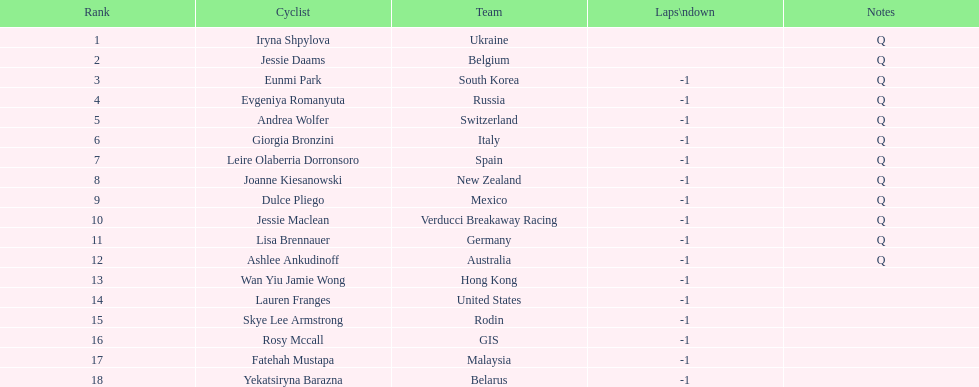Could you help me parse every detail presented in this table? {'header': ['Rank', 'Cyclist', 'Team', 'Laps\\ndown', 'Notes'], 'rows': [['1', 'Iryna Shpylova', 'Ukraine', '', 'Q'], ['2', 'Jessie Daams', 'Belgium', '', 'Q'], ['3', 'Eunmi Park', 'South Korea', '-1', 'Q'], ['4', 'Evgeniya Romanyuta', 'Russia', '-1', 'Q'], ['5', 'Andrea Wolfer', 'Switzerland', '-1', 'Q'], ['6', 'Giorgia Bronzini', 'Italy', '-1', 'Q'], ['7', 'Leire Olaberria Dorronsoro', 'Spain', '-1', 'Q'], ['8', 'Joanne Kiesanowski', 'New Zealand', '-1', 'Q'], ['9', 'Dulce Pliego', 'Mexico', '-1', 'Q'], ['10', 'Jessie Maclean', 'Verducci Breakaway Racing', '-1', 'Q'], ['11', 'Lisa Brennauer', 'Germany', '-1', 'Q'], ['12', 'Ashlee Ankudinoff', 'Australia', '-1', 'Q'], ['13', 'Wan Yiu Jamie Wong', 'Hong Kong', '-1', ''], ['14', 'Lauren Franges', 'United States', '-1', ''], ['15', 'Skye Lee Armstrong', 'Rodin', '-1', ''], ['16', 'Rosy Mccall', 'GIS', '-1', ''], ['17', 'Fatehah Mustapa', 'Malaysia', '-1', ''], ['18', 'Yekatsiryna Barazna', 'Belarus', '-1', '']]} What is the numerical standing of belgium? 2. 